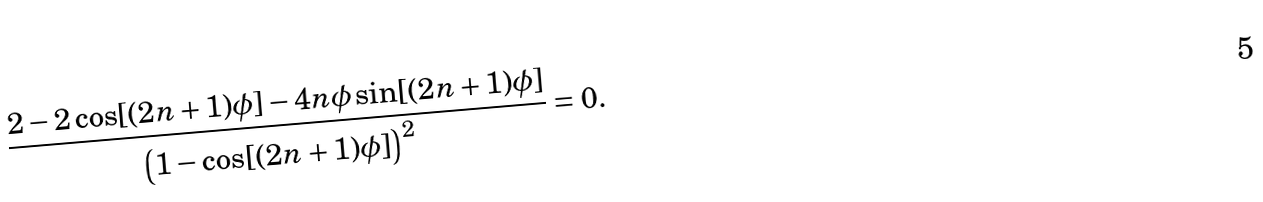<formula> <loc_0><loc_0><loc_500><loc_500>\frac { 2 - 2 \cos [ ( 2 n + 1 ) \phi ] - 4 n \phi \sin [ ( 2 n + 1 ) \phi ] } { \left ( 1 - \cos [ ( 2 n + 1 ) \phi ] \right ) ^ { 2 } } = 0 .</formula> 